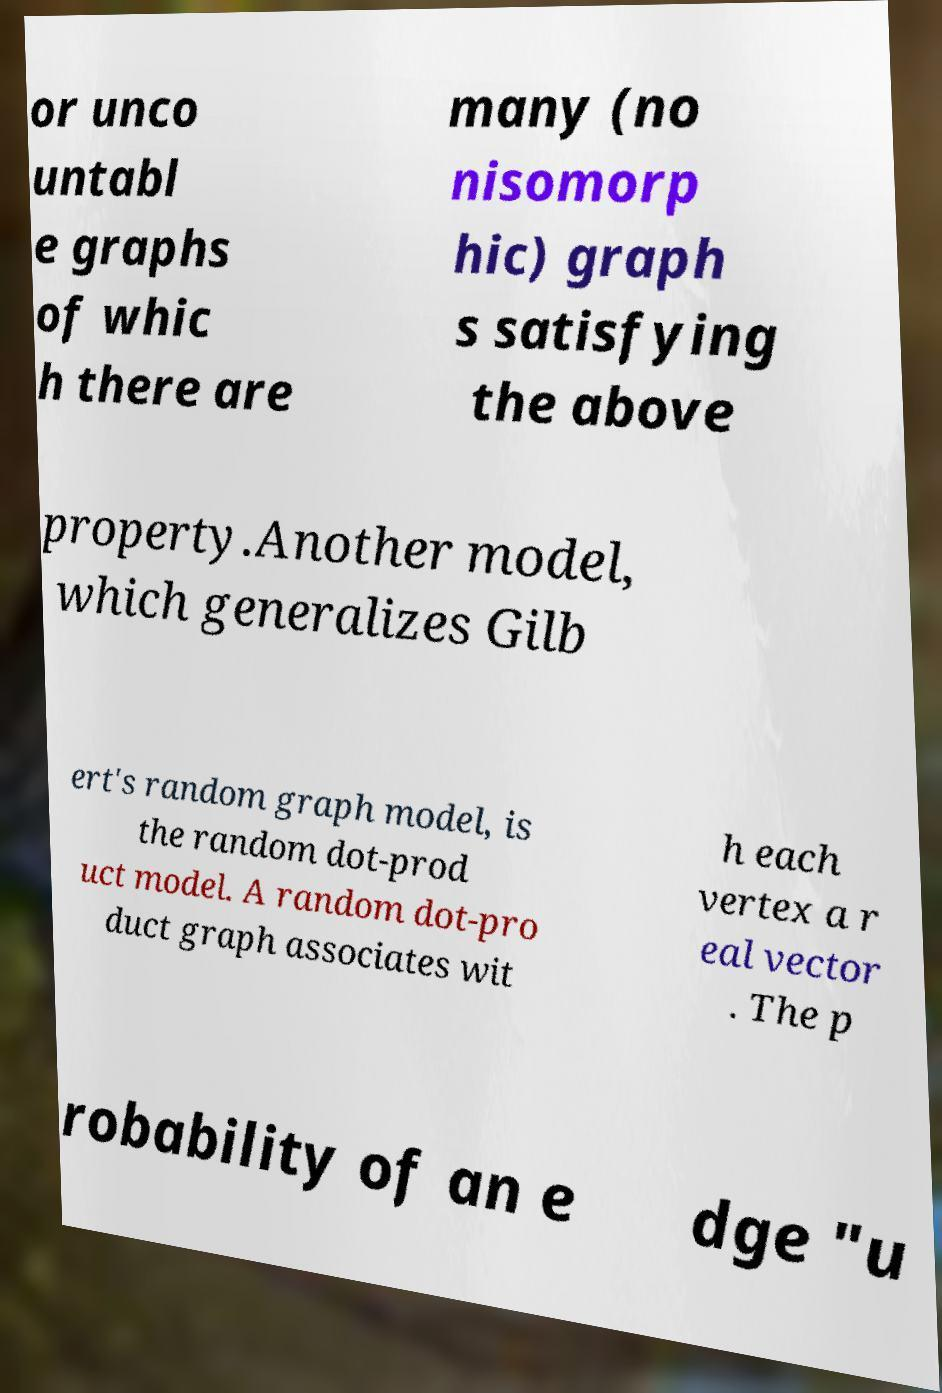Could you assist in decoding the text presented in this image and type it out clearly? or unco untabl e graphs of whic h there are many (no nisomorp hic) graph s satisfying the above property.Another model, which generalizes Gilb ert's random graph model, is the random dot-prod uct model. A random dot-pro duct graph associates wit h each vertex a r eal vector . The p robability of an e dge "u 